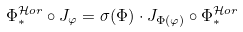<formula> <loc_0><loc_0><loc_500><loc_500>\Phi _ { \ast } ^ { \mathcal { H } o r } \circ J _ { \varphi } = \sigma ( \Phi ) \cdot J _ { \Phi ( \varphi ) } \circ \Phi _ { \ast } ^ { \mathcal { H } o r }</formula> 